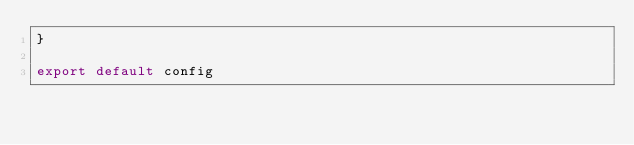<code> <loc_0><loc_0><loc_500><loc_500><_JavaScript_>}

export default config
</code> 